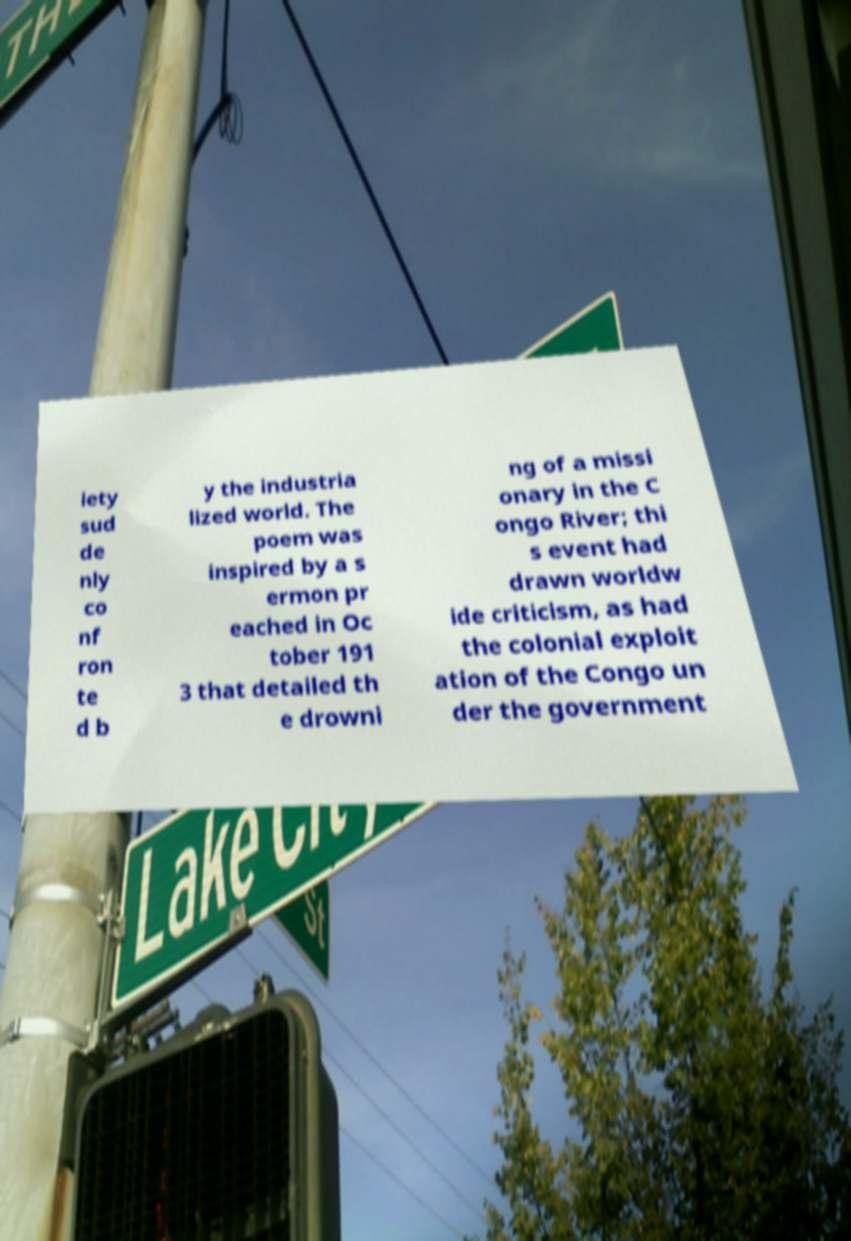I need the written content from this picture converted into text. Can you do that? iety sud de nly co nf ron te d b y the industria lized world. The poem was inspired by a s ermon pr eached in Oc tober 191 3 that detailed th e drowni ng of a missi onary in the C ongo River; thi s event had drawn worldw ide criticism, as had the colonial exploit ation of the Congo un der the government 